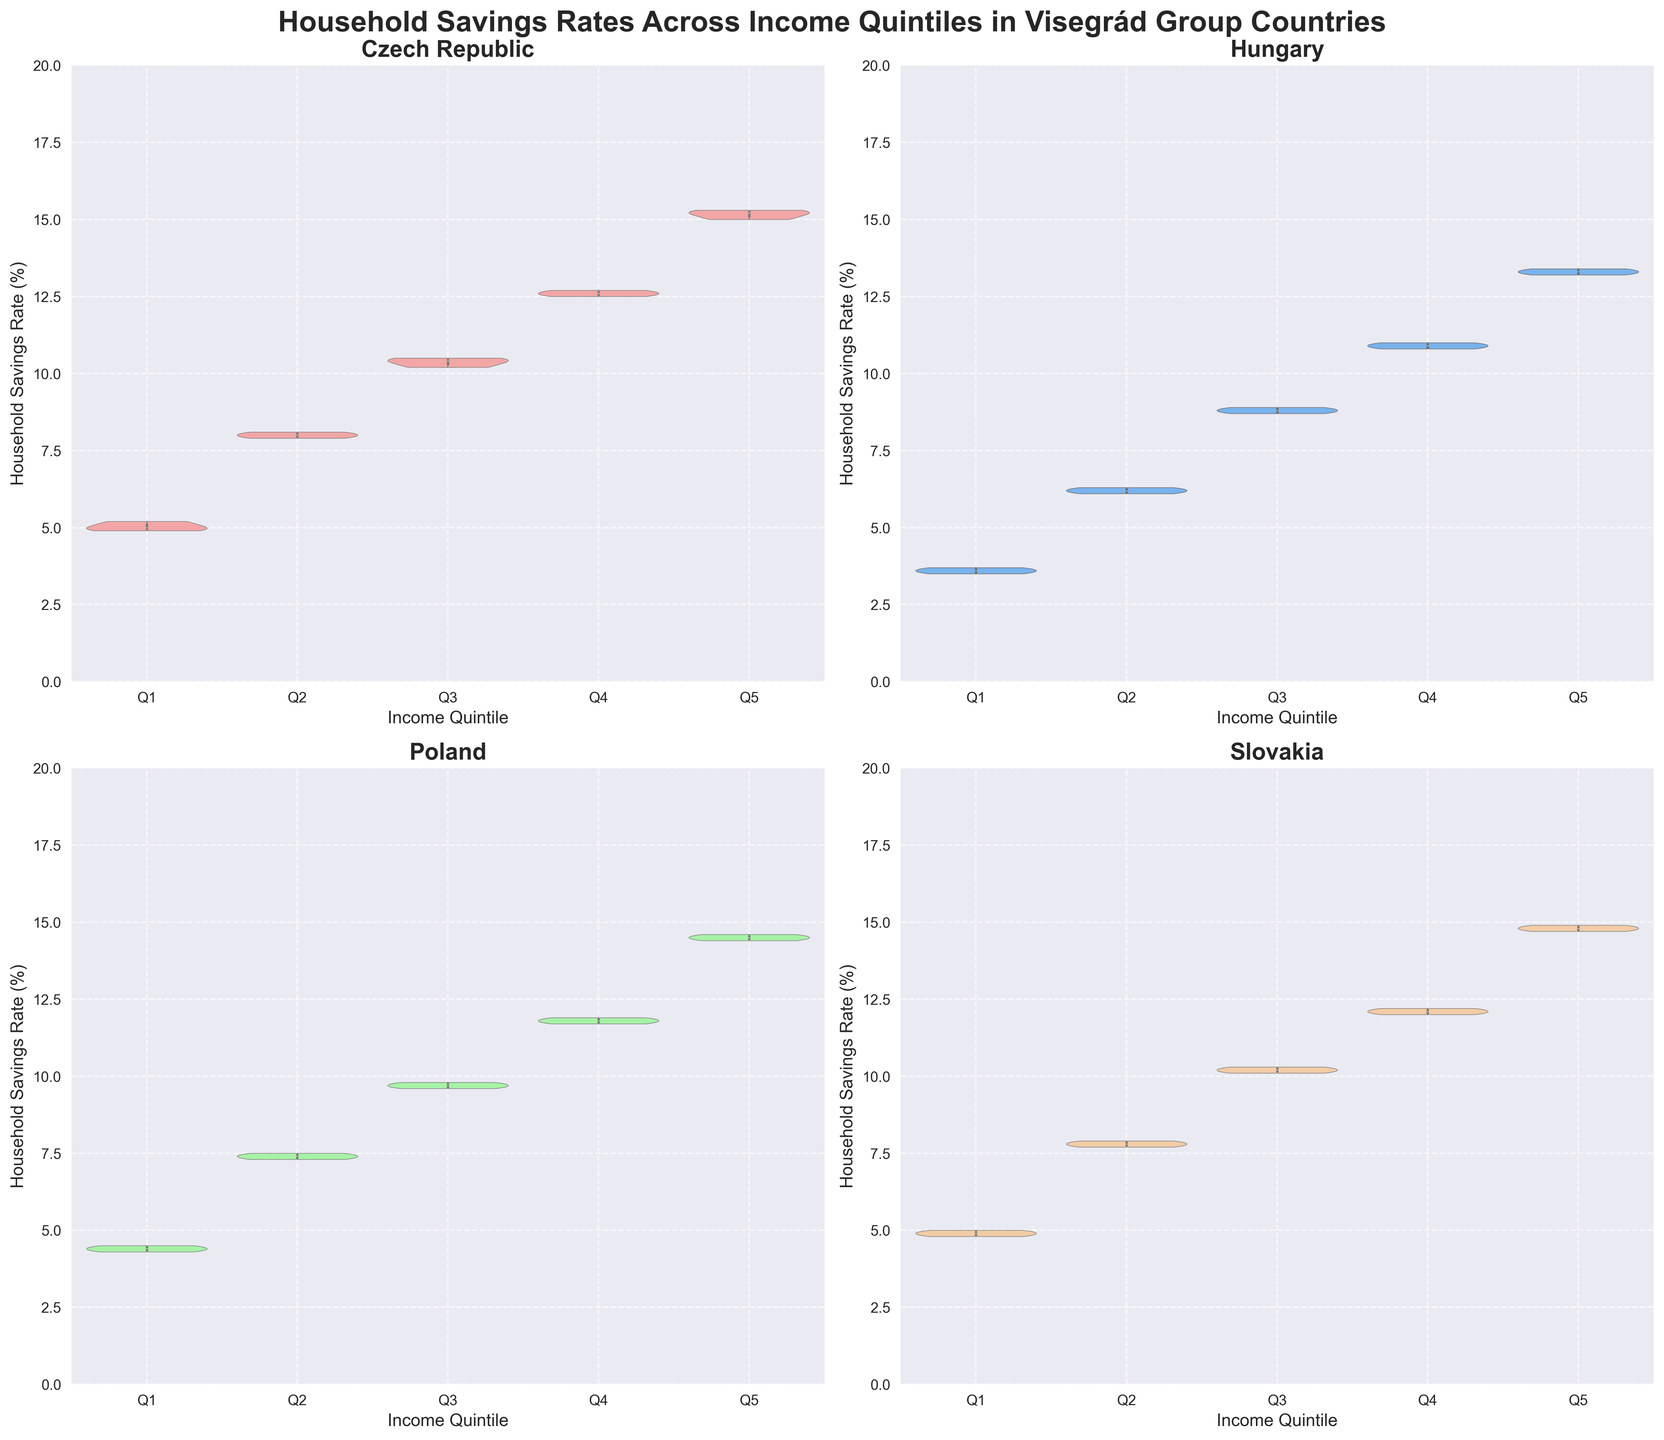What are the titles of the subplots? Each subplot represents a different country in the Visegrád Group. The titles of the subplots are derived from the data about household savings rates and are located at the top of each respective subplot. The countries are "Czech Republic," "Hungary," "Poland," and "Slovakia."
Answer: Czech Republic, Hungary, Poland, Slovakia Which Income Quintile shows the highest household savings rate in the Czech Republic? To determine the highest household savings rate in the Czech Republic, look at the violin plot for the Czech Republic. Observe the distribution of the savings rates across the quintiles Q1 to Q5, and identify which has the highest median or upper whisker.
Answer: Q5 What is the range of household savings rates for Q1 in Slovakia? Look at the violin plot for Slovakia, specifically at the Q1 section. The range can be identified by the lower and upper bounds of the violin plot for Q1. In this plot, it's between approximately 4.8% and 5.0%.
Answer: 4.8% - 5.0% How does the median household savings rate for Q3 in Poland compare to Q3 in Hungary? Compare the line inside the violin plots representing the median for Q3 in both Poland and Hungary. The Q3 median savings rate in Poland is around 9.7%, whereas in Hungary, it is around 8.8%.
Answer: Poland's median is higher What is the median savings rate for the highest income quintile (Q5) in Hungary? Locate the Hungary subplot, and examine the Q5 segment. The median rate is shown by the line in the center of the violin plot for Q5.
Answer: 13.3% Is there a country where household savings rates increase consistently from Q1 to Q5 without overlapping distributions? Check each subplot for gradual increases in the medians from Q1 to Q5 without overlapping violin shapes. The Czech Republic shows a clear incremental increase in household savings rate from Q1 to Q5 without any overlaps.
Answer: Czech Republic Which country shows the most varied (widest spread) savings rates in the highest income quintile (Q5)? Look at the width and spread of the violin plot for Q5 in each country. The Czech Republic’s Q5 violin plot appears to be the most varied in its distribution, indicating a wider spread of savings rates.
Answer: Czech Republic Is there any quintile in Poland where the savings rate distributions overlap significantly with the adjacent quintile? Examine the violin plot for Poland. The Q3 and Q4 savings rate distributions visibly overlap significantly, indicating similar savings rates within these two quintiles.
Answer: Yes, Q3 and Q4 Explain the overall trend in household savings rates as income quintiles increase for Slovakia. For Slovakia, there's a general upward trend in household savings rates from Q1 to Q5. Observing the subplots, each successive quintile has a higher savings rate median than the previous one, indicating higher savings as income increases.
Answer: Savings rates increase from Q1 to Q5 Which country has the lowest median household savings rate for Q2, and what is the value? By comparing the Q2 medians in each country’s subplot, it is evident that Hungary has the lowest median household savings rate for Q2, roughly around 6.2%.
Answer: Hungary, 6.2% 